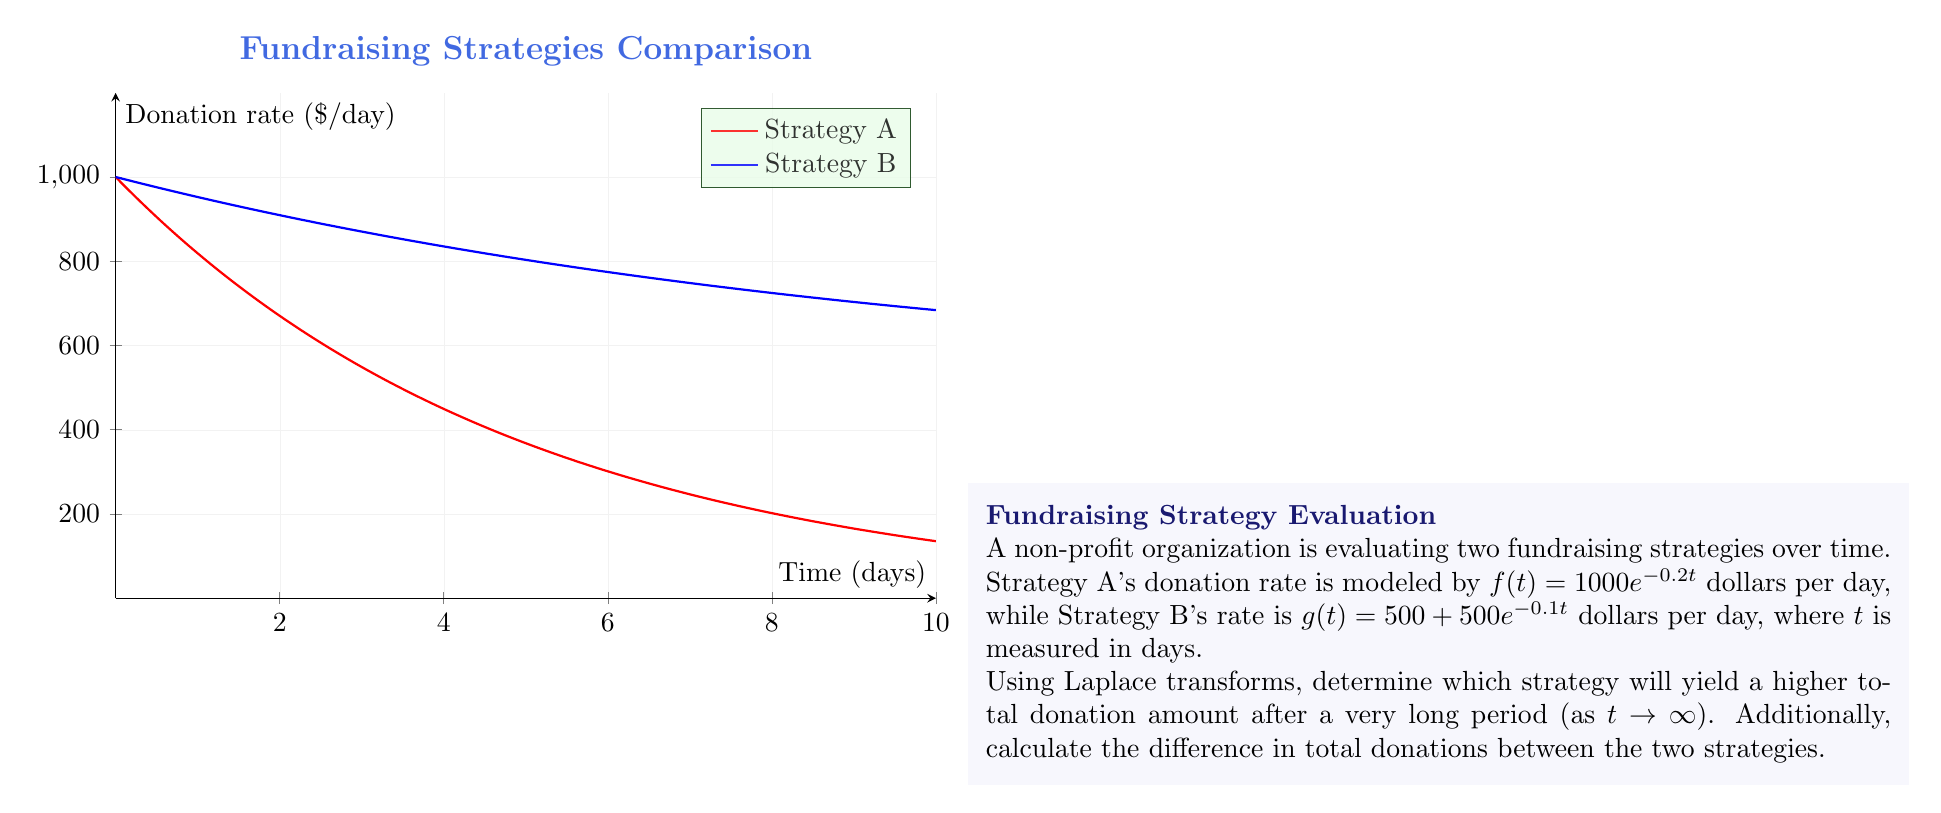Solve this math problem. Let's approach this step-by-step using Laplace transforms:

1) First, recall that the Laplace transform of a function $f(t)$ is defined as:

   $$F(s) = \mathcal{L}\{f(t)\} = \int_0^\infty f(t)e^{-st}dt$$

2) The total donation amount over all time is equivalent to the integral of the donation rate from 0 to infinity. This is precisely what we get when we evaluate the Laplace transform at $s = 0$.

3) For Strategy A:
   $$F(s) = \mathcal{L}\{1000e^{-0.2t}\} = \frac{1000}{s + 0.2}$$
   Total donations: $F(0) = \frac{1000}{0.2} = 5000$

4) For Strategy B:
   $$G(s) = \mathcal{L}\{500 + 500e^{-0.1t}\} = \frac{500}{s} + \frac{500}{s + 0.1}$$
   Total donations: $G(0) = \lim_{s \to 0} (\frac{500}{s} + \frac{500}{s + 0.1})$

5) To evaluate $G(0)$, we need to consider the limit:
   $$\lim_{s \to 0} \frac{500}{s} = \infty$$
   $$\lim_{s \to 0} \frac{500}{s + 0.1} = 5000$$

6) Therefore, $G(0) = \infty$, which means Strategy B will yield an infinite amount of donations over an infinite time period.

7) The difference in total donations is:
   $G(0) - F(0) = \infty - 5000 = \infty$
Answer: Strategy B yields higher donations; difference is infinite. 